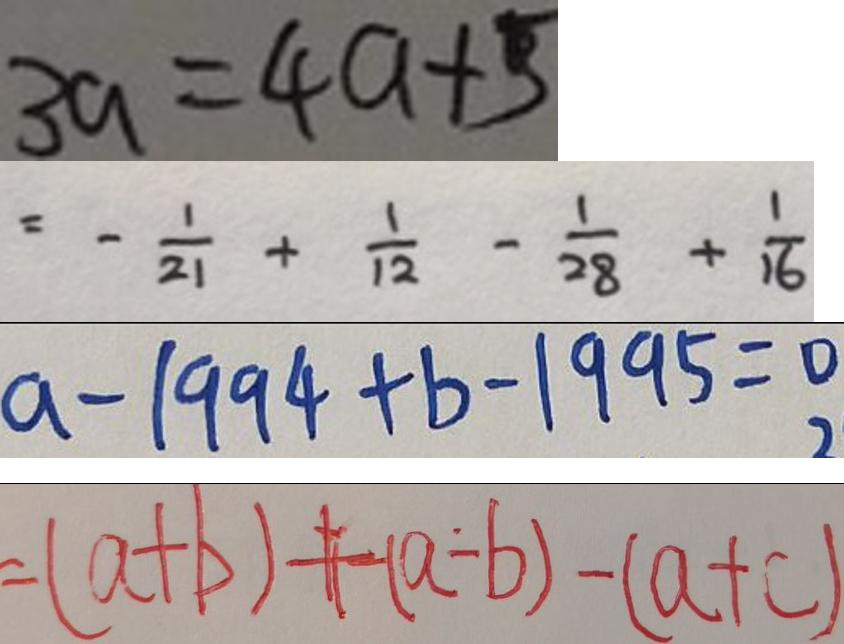Convert formula to latex. <formula><loc_0><loc_0><loc_500><loc_500>3 a = 4 a + 5 
 = - \frac { 1 } { 2 1 } + \frac { 1 } { 1 2 } - \frac { 1 } { 2 8 } + \frac { 1 } { 1 6 } 
 a - 1 9 9 4 + b - 1 9 9 5 = 0 
 = ( a + b ) + ( a - b ) - ( a + c )</formula> 